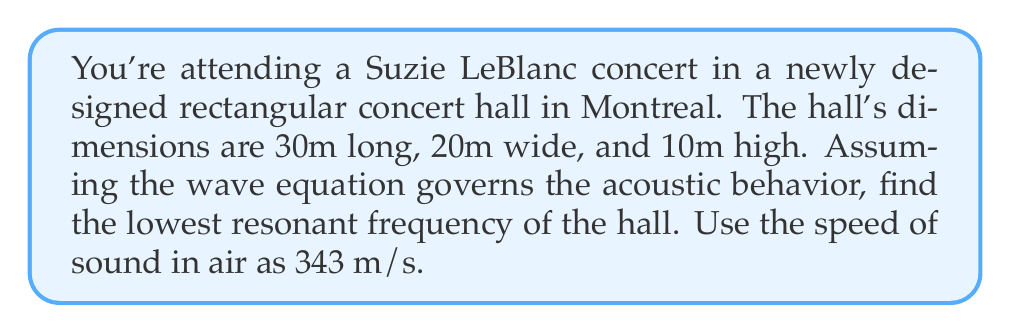Can you solve this math problem? To solve this problem, we'll use the wave equation for a rectangular room and determine the lowest resonant frequency.

1) The wave equation for a rectangular room is:

   $$\frac{\partial^2 p}{\partial t^2} = c^2 \left(\frac{\partial^2 p}{\partial x^2} + \frac{\partial^2 p}{\partial y^2} + \frac{\partial^2 p}{\partial z^2}\right)$$

   where $p$ is pressure, $t$ is time, $c$ is the speed of sound, and $x$, $y$, $z$ are spatial coordinates.

2) The solution for standing waves in a rectangular room is:

   $$p(x,y,z,t) = A \cos(\omega t) \cos(\frac{n_x \pi x}{L_x}) \cos(\frac{n_y \pi y}{L_y}) \cos(\frac{n_z \pi z}{L_z})$$

   where $L_x$, $L_y$, $L_z$ are the room dimensions, and $n_x$, $n_y$, $n_z$ are non-negative integers.

3) The resonant frequencies are given by:

   $$f = \frac{c}{2} \sqrt{\left(\frac{n_x}{L_x}\right)^2 + \left(\frac{n_y}{L_y}\right)^2 + \left(\frac{n_z}{L_z}\right)^2}$$

4) The lowest resonant frequency occurs when $n_x = 1$, $n_y = 0$, and $n_z = 0$. Substituting these values:

   $$f = \frac{343}{2} \sqrt{\left(\frac{1}{30}\right)^2 + \left(\frac{0}{20}\right)^2 + \left(\frac{0}{10}\right)^2}$$

5) Simplifying:

   $$f = \frac{343}{2} \cdot \frac{1}{30} = 5.7166... \text{ Hz}$$

Thus, the lowest resonant frequency is approximately 5.72 Hz.
Answer: The lowest resonant frequency of the concert hall is approximately 5.72 Hz. 